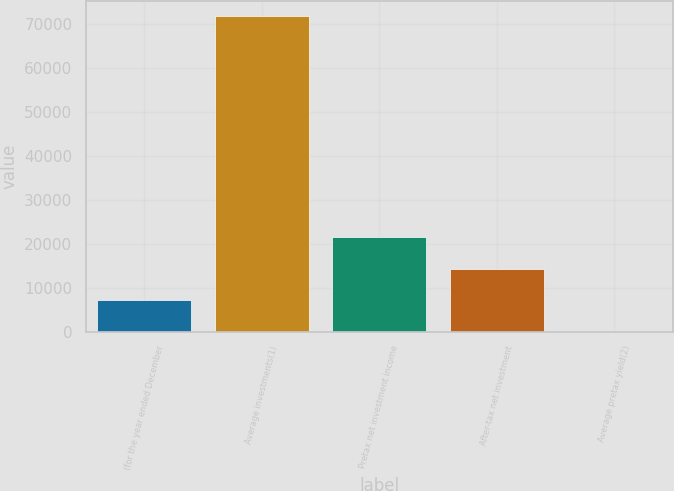Convert chart. <chart><loc_0><loc_0><loc_500><loc_500><bar_chart><fcel>(for the year ended December<fcel>Average investments(1)<fcel>Pretax net investment income<fcel>After-tax net investment<fcel>Average pretax yield(2)<nl><fcel>7167.57<fcel>71637<fcel>21494.1<fcel>14330.8<fcel>4.3<nl></chart> 